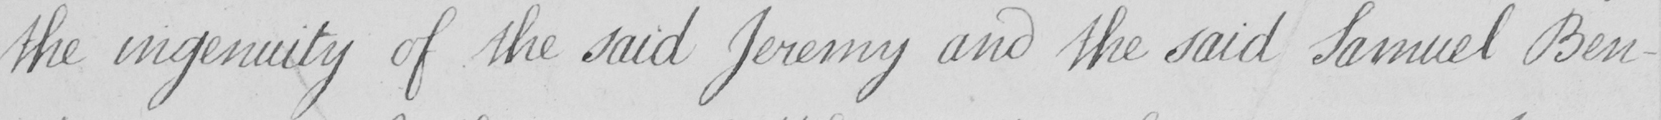Please provide the text content of this handwritten line. the ingenuity of the said Jeremy and the said Samuel Ben- 